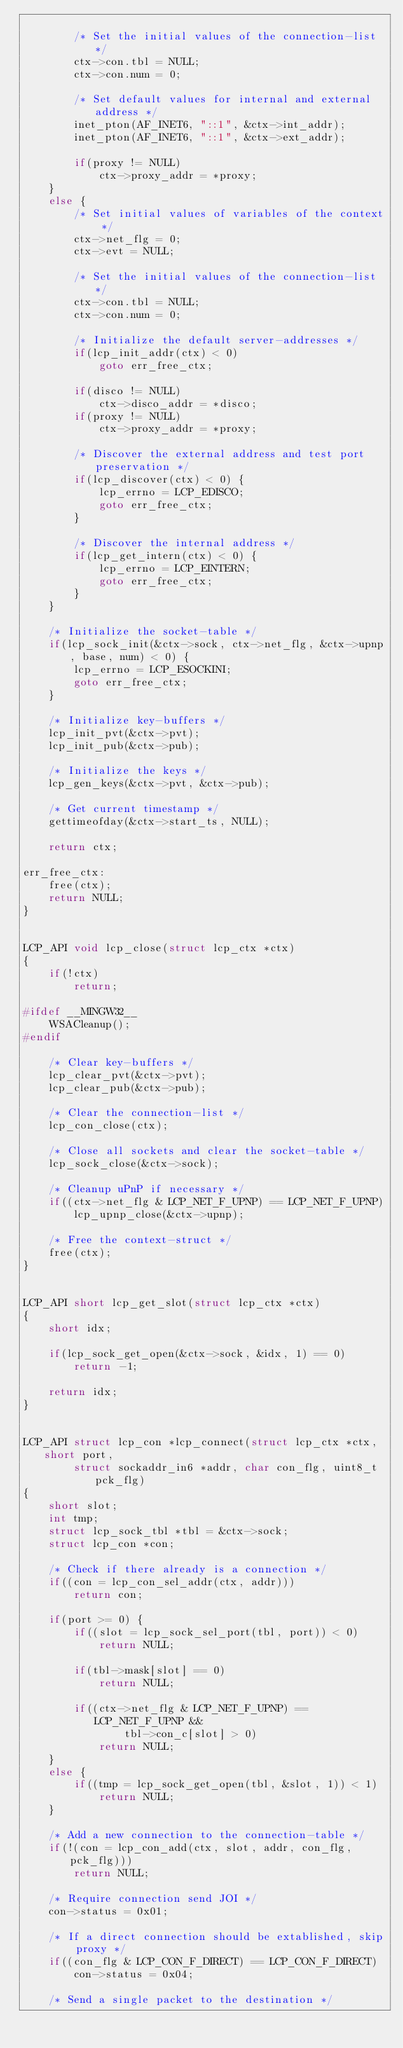<code> <loc_0><loc_0><loc_500><loc_500><_C_>
		/* Set the initial values of the connection-list */
		ctx->con.tbl = NULL;
		ctx->con.num = 0;

		/* Set default values for internal and external address */
		inet_pton(AF_INET6, "::1", &ctx->int_addr);
		inet_pton(AF_INET6, "::1", &ctx->ext_addr);

		if(proxy != NULL)
			ctx->proxy_addr = *proxy;
	}
	else {
		/* Set initial values of variables of the context */
		ctx->net_flg = 0;
		ctx->evt = NULL;

		/* Set the initial values of the connection-list */
		ctx->con.tbl = NULL;
		ctx->con.num = 0;

		/* Initialize the default server-addresses */
		if(lcp_init_addr(ctx) < 0)
			goto err_free_ctx;

		if(disco != NULL)
			ctx->disco_addr = *disco;
		if(proxy != NULL)
			ctx->proxy_addr = *proxy;

		/* Discover the external address and test port preservation */
		if(lcp_discover(ctx) < 0) {
			lcp_errno = LCP_EDISCO;
			goto err_free_ctx;
		}

		/* Discover the internal address */
		if(lcp_get_intern(ctx) < 0) {
			lcp_errno = LCP_EINTERN;
			goto err_free_ctx;
		}
	}

	/* Initialize the socket-table */
	if(lcp_sock_init(&ctx->sock, ctx->net_flg, &ctx->upnp, base, num) < 0) {
		lcp_errno = LCP_ESOCKINI;
		goto err_free_ctx;
	}

	/* Initialize key-buffers */
	lcp_init_pvt(&ctx->pvt);
	lcp_init_pub(&ctx->pub);

	/* Initialize the keys */
	lcp_gen_keys(&ctx->pvt, &ctx->pub);

	/* Get current timestamp */
	gettimeofday(&ctx->start_ts, NULL);

	return ctx;

err_free_ctx:
	free(ctx);
	return NULL;
}


LCP_API void lcp_close(struct lcp_ctx *ctx)
{
	if(!ctx)
		return;

#ifdef __MINGW32__
	WSACleanup();
#endif

	/* Clear key-buffers */
	lcp_clear_pvt(&ctx->pvt);
	lcp_clear_pub(&ctx->pub);

	/* Clear the connection-list */
	lcp_con_close(ctx);

	/* Close all sockets and clear the socket-table */
	lcp_sock_close(&ctx->sock);

	/* Cleanup uPnP if necessary */
	if((ctx->net_flg & LCP_NET_F_UPNP) == LCP_NET_F_UPNP)
		lcp_upnp_close(&ctx->upnp);

	/* Free the context-struct */
	free(ctx);
}


LCP_API short lcp_get_slot(struct lcp_ctx *ctx)
{
	short idx;

	if(lcp_sock_get_open(&ctx->sock, &idx, 1) == 0)
		return -1;

	return idx;
}


LCP_API struct lcp_con *lcp_connect(struct lcp_ctx *ctx, short port, 
		struct sockaddr_in6 *addr, char con_flg, uint8_t pck_flg)
{
	short slot;
	int tmp;
	struct lcp_sock_tbl *tbl = &ctx->sock;
	struct lcp_con *con;

	/* Check if there already is a connection */
	if((con = lcp_con_sel_addr(ctx, addr)))
		return con;

	if(port >= 0) {
		if((slot = lcp_sock_sel_port(tbl, port)) < 0)
			return NULL;

		if(tbl->mask[slot] == 0)
			return NULL;

		if((ctx->net_flg & LCP_NET_F_UPNP) == LCP_NET_F_UPNP && 
				tbl->con_c[slot] > 0)
			return NULL;
	}
	else {
		if((tmp = lcp_sock_get_open(tbl, &slot, 1)) < 1)
			return NULL;
	}

	/* Add a new connection to the connection-table */
	if(!(con = lcp_con_add(ctx, slot, addr, con_flg, pck_flg)))
		return NULL;

	/* Require connection send JOI */
	con->status = 0x01;

	/* If a direct connection should be extablished, skip proxy */
	if((con_flg & LCP_CON_F_DIRECT) == LCP_CON_F_DIRECT)
		con->status = 0x04;

	/* Send a single packet to the destination */</code> 